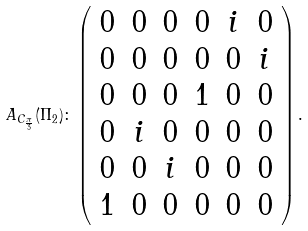<formula> <loc_0><loc_0><loc_500><loc_500>A _ { C _ { \frac { \pi } { 3 } } } ( \Pi _ { 2 } ) \colon \left ( \begin{array} { c c c c c c } 0 & 0 & 0 & 0 & i & 0 \\ 0 & 0 & 0 & 0 & 0 & i \\ 0 & 0 & 0 & 1 & 0 & 0 \\ 0 & i & 0 & 0 & 0 & 0 \\ 0 & 0 & i & 0 & 0 & 0 \\ 1 & 0 & 0 & 0 & 0 & 0 \end{array} \right ) .</formula> 